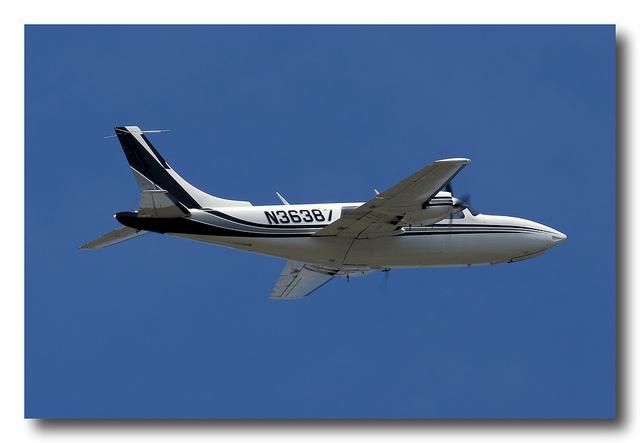What color is the airplane?
Be succinct. White. What are the numbers on plane?
Concise answer only. 3638. Is the sky clear?
Concise answer only. Yes. 